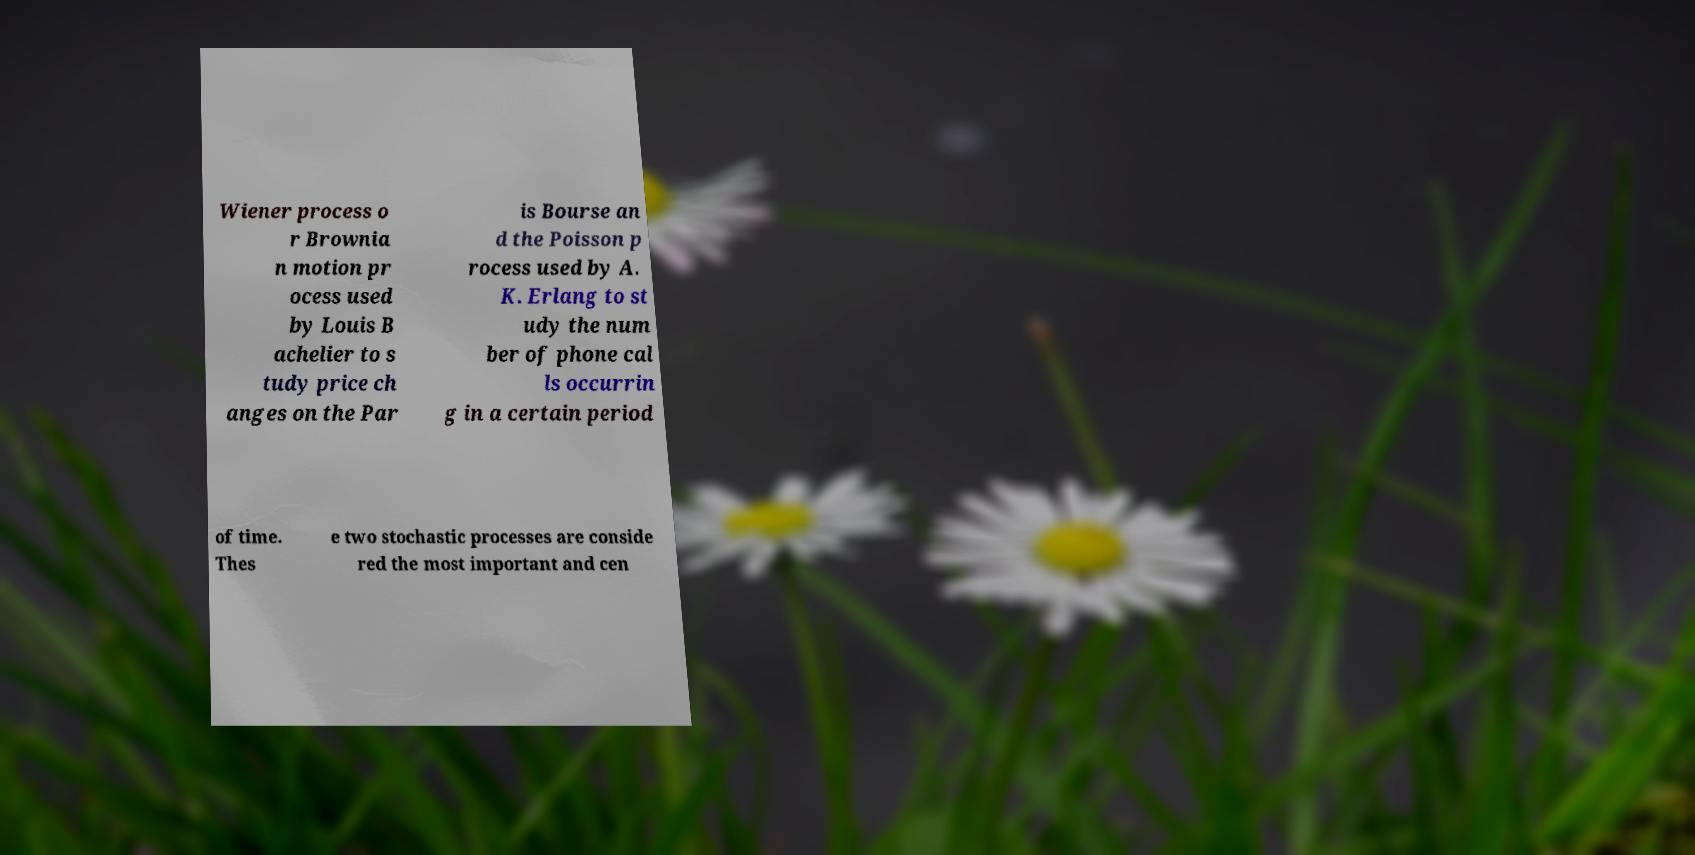Could you extract and type out the text from this image? Wiener process o r Brownia n motion pr ocess used by Louis B achelier to s tudy price ch anges on the Par is Bourse an d the Poisson p rocess used by A. K. Erlang to st udy the num ber of phone cal ls occurrin g in a certain period of time. Thes e two stochastic processes are conside red the most important and cen 